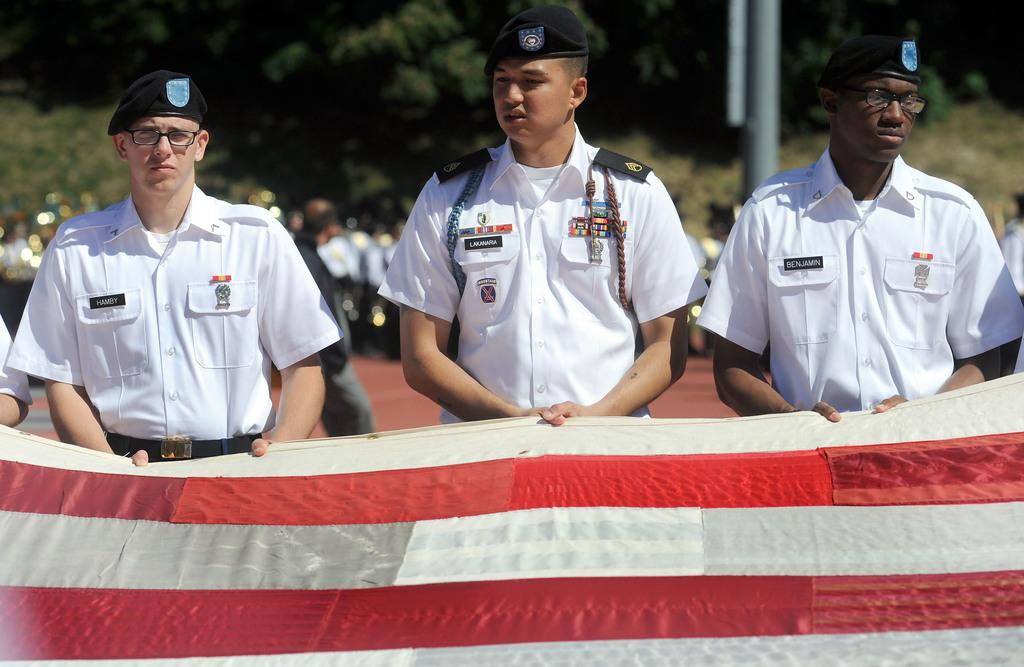How many navy officers are in the image? There are three navy officers in the image. What are the navy officers wearing? The navy officers are wearing white shirts. What are the navy officers holding in the image? The navy officers are holding a red and white flag. Can you describe the people in the background of the image? There are people standing in the background of the image. What type of neck is visible on the navy officers in the image? There is no specific neck type mentioned or visible in the image; the navy officers are wearing white shirts. Is the image taken during a sleet storm? The provided facts do not mention any weather conditions, so it cannot be determined if the image was taken during a sleet storm. 